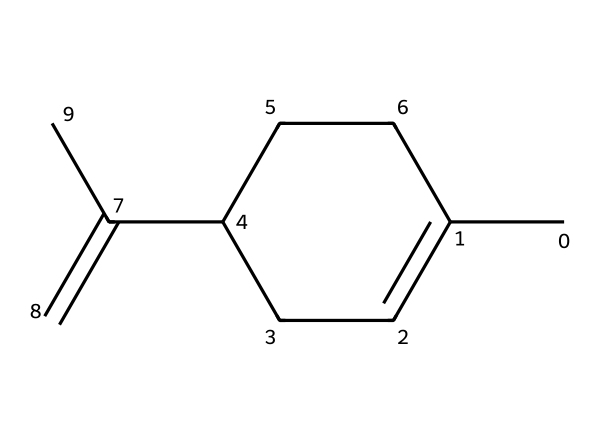What is the molecular formula of limonene? To determine the molecular formula, we count the number of carbon (C) and hydrogen (H) atoms in the structure. The SMILES notation indicates that there are 10 carbon atoms and 16 hydrogen atoms. Therefore, the molecular formula is C10H16.
Answer: C10H16 How many double bonds are present in limonene? In the given structure, I can identify two double bonds based on the presence of 'C(=C)' and the connections within the cyclic part. This means limonene has two double bonds.
Answer: 2 Is limonene a saturated or unsaturated compound? Since limonene contains double bonds (as identified earlier), it is classified as an unsaturated compound, meaning that it has fewer hydrogen atoms than a saturated compound with the same number of carbon atoms.
Answer: unsaturated What type of chemical is limonene classified as? Limonene is a terpene, which is a class of organic compounds made up of isoprene units. This classification can be derived from its structure, showing multiple carbon atoms in a cyclic formation and the presence of double bonds.
Answer: terpene Which part of the limonene structure is primarily responsible for its citrus scent? The specific arrangement of the double bonds in the molecular structure of limonene contributes to its characteristic citrus scent. The cyclic nature and the substituents around the double bonds create a unique olfactory profile.
Answer: double bonds 